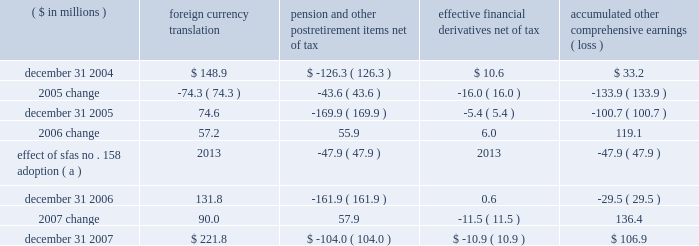Page 71 of 94 notes to consolidated financial statements ball corporation and subsidiaries 16 .
Shareholders 2019 equity ( continued ) on october 24 , 2007 , ball announced the discontinuance of the company 2019s discount on the reinvestment of dividends associated with the company 2019s dividend reinvestment and voluntary stock purchase plan for non- employee shareholders .
The 5 percent discount was discontinued on november 1 , 2007 .
Accumulated other comprehensive earnings ( loss ) the activity related to accumulated other comprehensive earnings ( loss ) was as follows : ( $ in millions ) foreign currency translation pension and postretirement items , net of tax effective financial derivatives , net of tax accumulated comprehensive earnings ( loss ) .
( a ) within the company 2019s 2006 annual report , the consolidated statement of changes in shareholders 2019 equity for the year ended december 31 , 2006 , included a transition adjustment of $ 47.9 million , net of tax , related to the adoption of sfas no .
158 , 201cemployers 2019 accounting for defined benefit pension plans and other postretirement plans , an amendment of fasb statements no .
87 , 88 , 106 and 132 ( r ) , 201d as a component of 2006 comprehensive earnings rather than only as an adjustment to accumulated other comprehensive loss .
The 2006 amounts have been revised to correct the previous reporting .
Notwithstanding the 2005 distribution pursuant to the jobs act , management 2019s intention is to indefinitely reinvest foreign earnings .
Therefore , no taxes have been provided on the foreign currency translation component for any period .
The change in the pension and other postretirement items is presented net of related tax expense of $ 31.3 million and $ 2.9 million for 2007 and 2006 , respectively , and a related tax benefit of $ 27.3 million for 2005 .
The change in the effective financial derivatives is presented net of related tax benefit of $ 3.2 million for 2007 , related tax expense of $ 5.7 million for 2006 and related tax benefit of $ 10.7 million for 2005 .
Stock-based compensation programs effective january 1 , 2006 , ball adopted sfas no .
123 ( revised 2004 ) , 201cshare based payment , 201d which is a revision of sfas no .
123 and supersedes apb opinion no .
25 .
The new standard establishes accounting standards for transactions in which an entity exchanges its equity instruments for goods or services , including stock option and restricted stock grants .
The major differences for ball are that ( 1 ) expense is now recorded in the consolidated statements of earnings for the fair value of new stock option grants and nonvested portions of grants made prior to january 1 , 2006 , and ( 2 ) the company 2019s deposit share program ( discussed below ) is no longer a variable plan that is marked to current market value each month through earnings .
Upon adoption of sfas no .
123 ( revised 2004 ) , ball has chosen to use the modified prospective transition method and the black-scholes valuation model. .
What was the percentage change in accumulated other comprehensive earnings ( loss ) between 2005 and 2006?\\n? 
Computations: ((-29.5 - -100.7) / 100.7)
Answer: 0.70705. Page 71 of 94 notes to consolidated financial statements ball corporation and subsidiaries 16 .
Shareholders 2019 equity ( continued ) on october 24 , 2007 , ball announced the discontinuance of the company 2019s discount on the reinvestment of dividends associated with the company 2019s dividend reinvestment and voluntary stock purchase plan for non- employee shareholders .
The 5 percent discount was discontinued on november 1 , 2007 .
Accumulated other comprehensive earnings ( loss ) the activity related to accumulated other comprehensive earnings ( loss ) was as follows : ( $ in millions ) foreign currency translation pension and postretirement items , net of tax effective financial derivatives , net of tax accumulated comprehensive earnings ( loss ) .
( a ) within the company 2019s 2006 annual report , the consolidated statement of changes in shareholders 2019 equity for the year ended december 31 , 2006 , included a transition adjustment of $ 47.9 million , net of tax , related to the adoption of sfas no .
158 , 201cemployers 2019 accounting for defined benefit pension plans and other postretirement plans , an amendment of fasb statements no .
87 , 88 , 106 and 132 ( r ) , 201d as a component of 2006 comprehensive earnings rather than only as an adjustment to accumulated other comprehensive loss .
The 2006 amounts have been revised to correct the previous reporting .
Notwithstanding the 2005 distribution pursuant to the jobs act , management 2019s intention is to indefinitely reinvest foreign earnings .
Therefore , no taxes have been provided on the foreign currency translation component for any period .
The change in the pension and other postretirement items is presented net of related tax expense of $ 31.3 million and $ 2.9 million for 2007 and 2006 , respectively , and a related tax benefit of $ 27.3 million for 2005 .
The change in the effective financial derivatives is presented net of related tax benefit of $ 3.2 million for 2007 , related tax expense of $ 5.7 million for 2006 and related tax benefit of $ 10.7 million for 2005 .
Stock-based compensation programs effective january 1 , 2006 , ball adopted sfas no .
123 ( revised 2004 ) , 201cshare based payment , 201d which is a revision of sfas no .
123 and supersedes apb opinion no .
25 .
The new standard establishes accounting standards for transactions in which an entity exchanges its equity instruments for goods or services , including stock option and restricted stock grants .
The major differences for ball are that ( 1 ) expense is now recorded in the consolidated statements of earnings for the fair value of new stock option grants and nonvested portions of grants made prior to january 1 , 2006 , and ( 2 ) the company 2019s deposit share program ( discussed below ) is no longer a variable plan that is marked to current market value each month through earnings .
Upon adoption of sfas no .
123 ( revised 2004 ) , ball has chosen to use the modified prospective transition method and the black-scholes valuation model. .
What was the percentage change in accumulated other comprehensive earnings ( loss ) between 2006 and 2007?\\n? 
Computations: ((106.9 - -29.5) / 29.5)
Answer: 4.62373. 